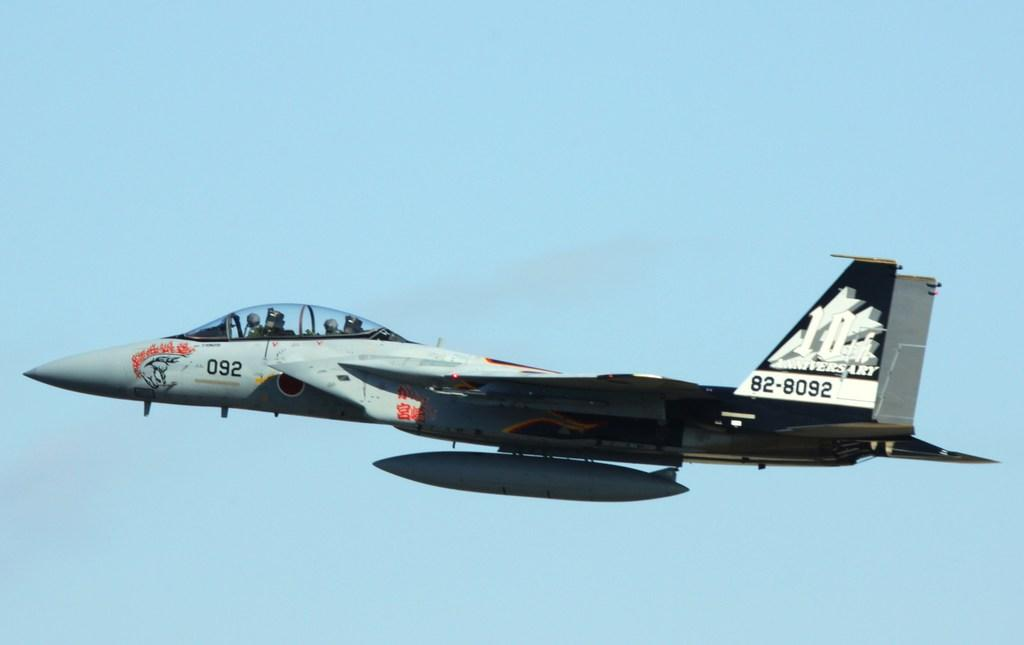<image>
Summarize the visual content of the image. The jet that is soaring throughout he sky is labelled "092" at the front of it. 